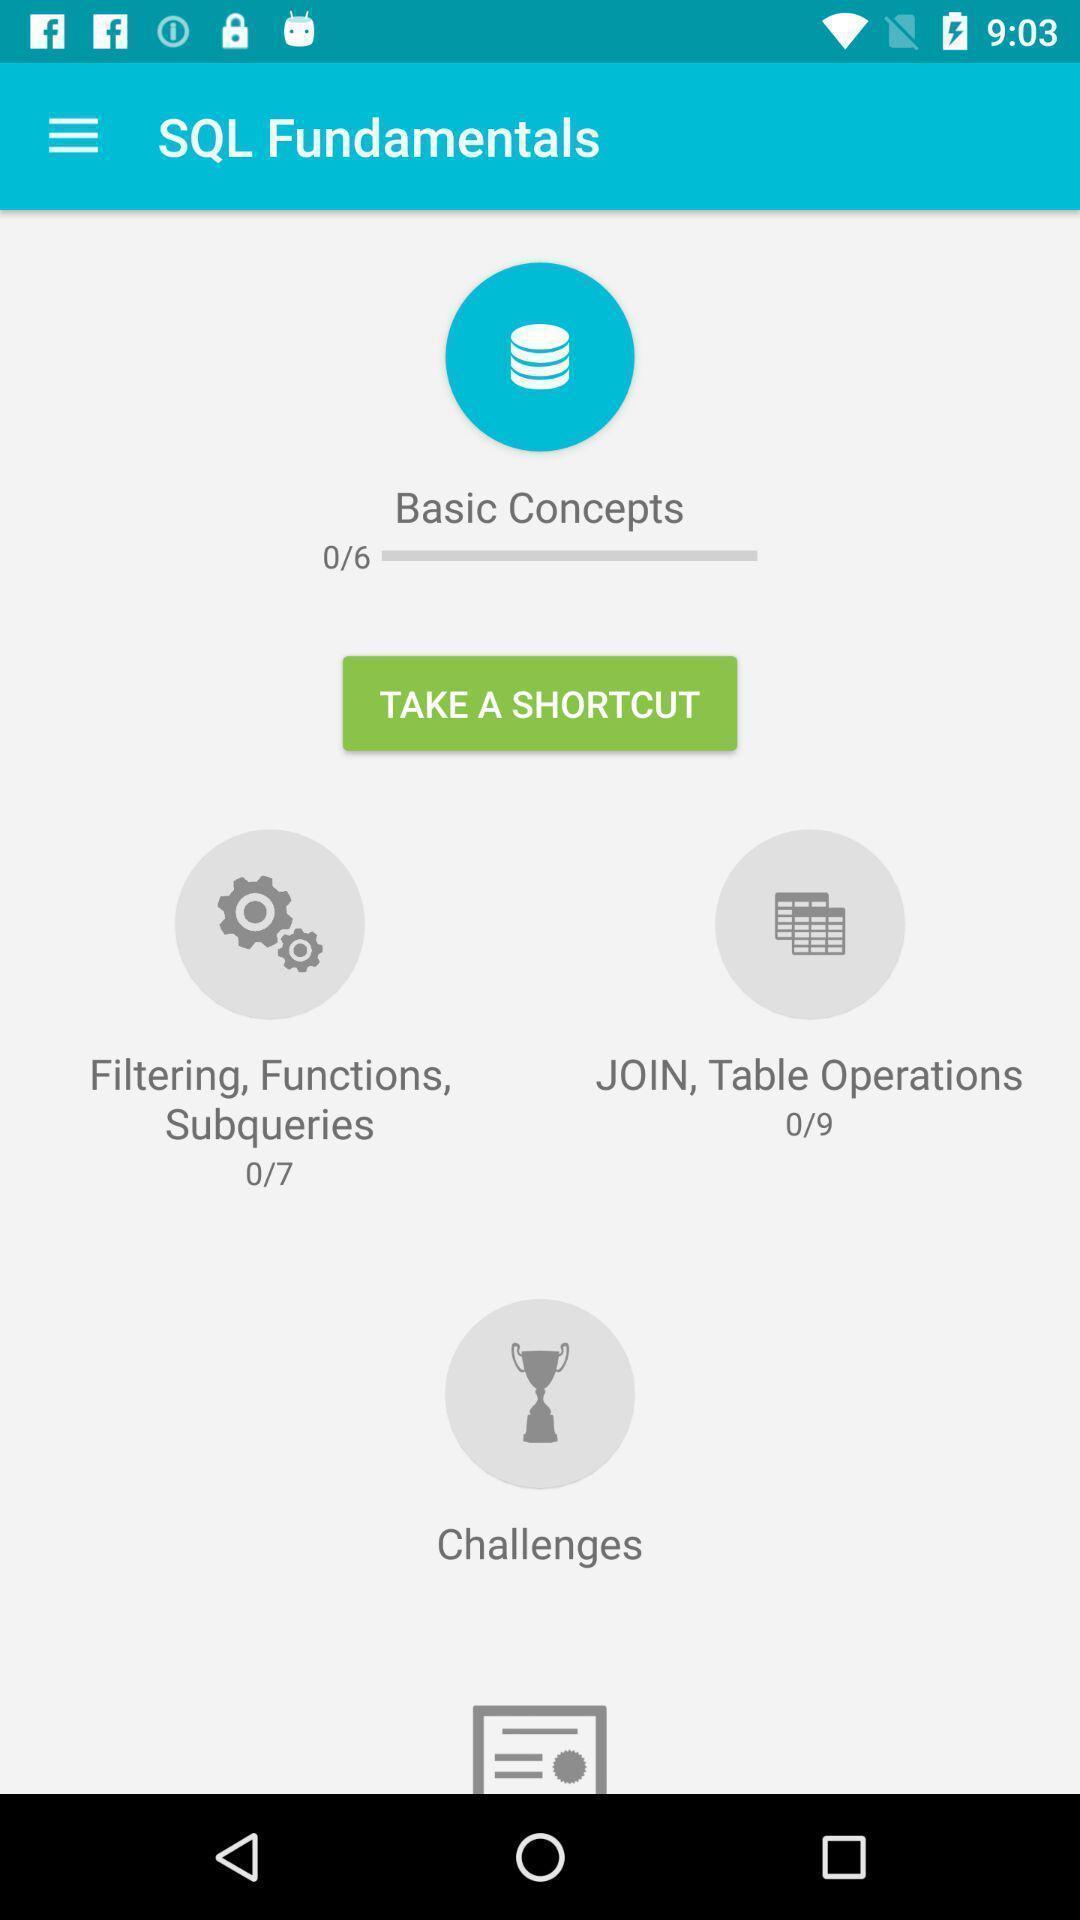Give me a narrative description of this picture. Screen displaying page of an learning application. 